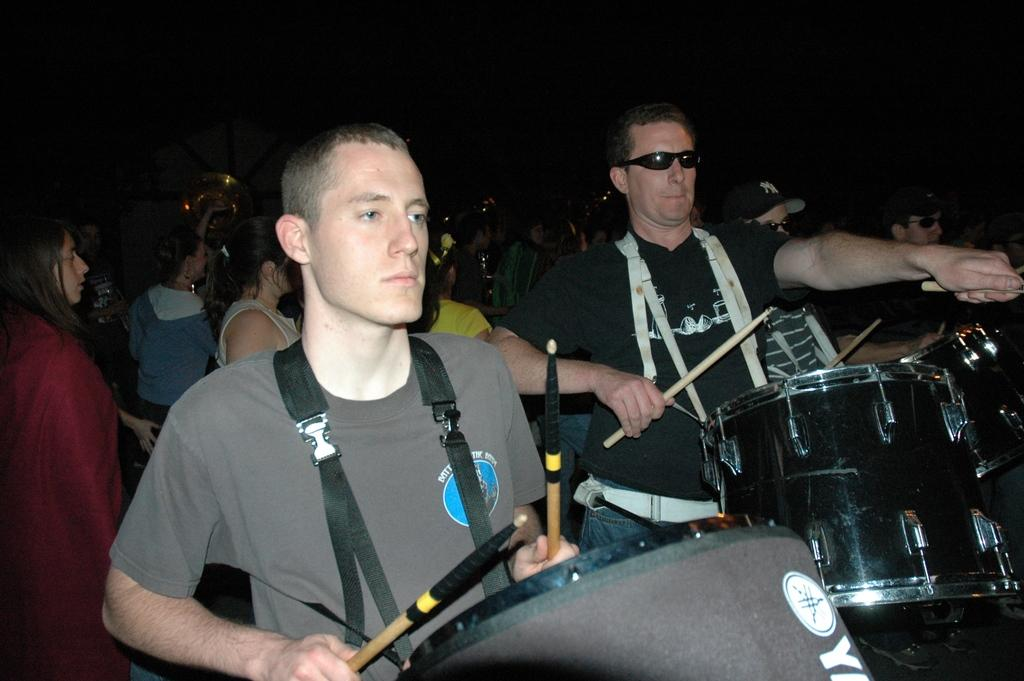How many people are playing drums in the image? There are two people in the image, and they are both playing drums. What are the drum players holding in their hands? The two people are holding drums. What are the drum players doing with the drums? The two people are playing the drums. Are there any other people visible in the image? Yes, there are other people visible behind the two drum players. What type of cactus can be seen growing in the background of the image? There is no cactus visible in the image; it features two people playing drums and other people behind them. 